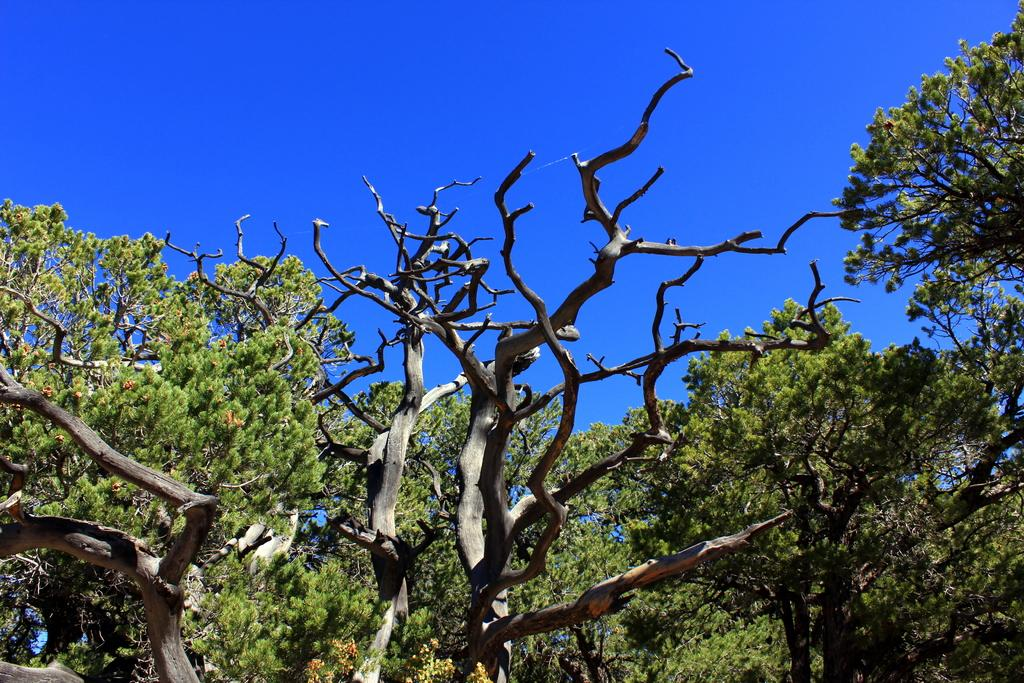What type of vegetation can be seen in the image? There are trees in the image. What part of the natural environment is visible in the image? The sky is visible in the background of the image. How many cans of soda are present at the party in the image? There is no party or cans of soda present in the image; it features trees and the sky. 